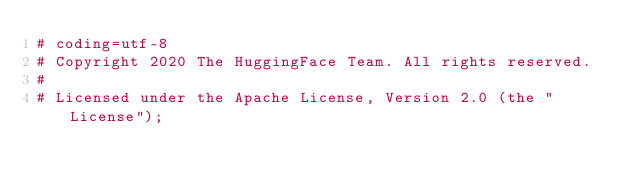<code> <loc_0><loc_0><loc_500><loc_500><_Python_># coding=utf-8
# Copyright 2020 The HuggingFace Team. All rights reserved.
#
# Licensed under the Apache License, Version 2.0 (the "License");</code> 